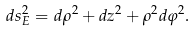Convert formula to latex. <formula><loc_0><loc_0><loc_500><loc_500>d s ^ { 2 } _ { E } = d \rho ^ { 2 } + d z ^ { 2 } + \rho ^ { 2 } d \varphi ^ { 2 } .</formula> 